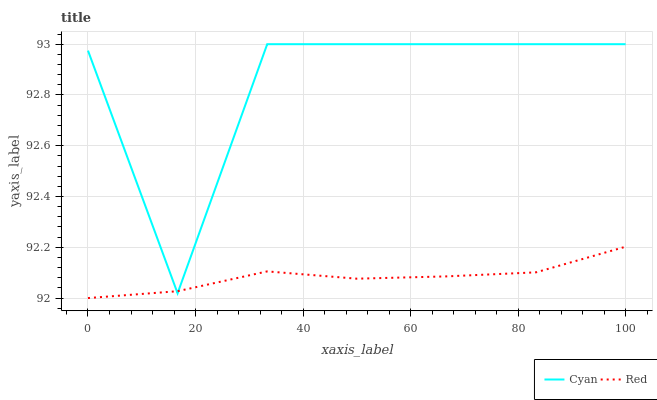Does Red have the minimum area under the curve?
Answer yes or no. Yes. Does Cyan have the maximum area under the curve?
Answer yes or no. Yes. Does Red have the maximum area under the curve?
Answer yes or no. No. Is Red the smoothest?
Answer yes or no. Yes. Is Cyan the roughest?
Answer yes or no. Yes. Is Red the roughest?
Answer yes or no. No. Does Red have the lowest value?
Answer yes or no. Yes. Does Cyan have the highest value?
Answer yes or no. Yes. Does Red have the highest value?
Answer yes or no. No. Does Red intersect Cyan?
Answer yes or no. Yes. Is Red less than Cyan?
Answer yes or no. No. Is Red greater than Cyan?
Answer yes or no. No. 